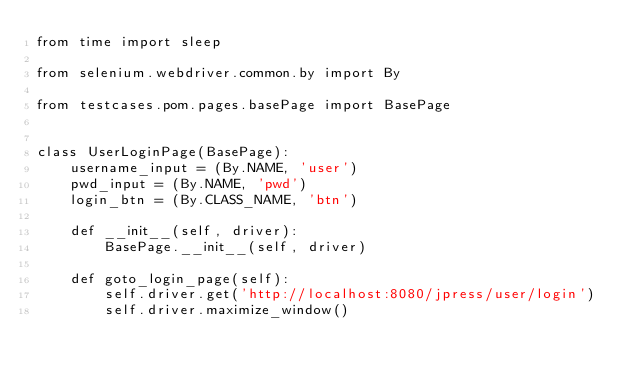Convert code to text. <code><loc_0><loc_0><loc_500><loc_500><_Python_>from time import sleep

from selenium.webdriver.common.by import By

from testcases.pom.pages.basePage import BasePage


class UserLoginPage(BasePage):
    username_input = (By.NAME, 'user')
    pwd_input = (By.NAME, 'pwd')
    login_btn = (By.CLASS_NAME, 'btn')

    def __init__(self, driver):
        BasePage.__init__(self, driver)

    def goto_login_page(self):
        self.driver.get('http://localhost:8080/jpress/user/login')
        self.driver.maximize_window()
</code> 